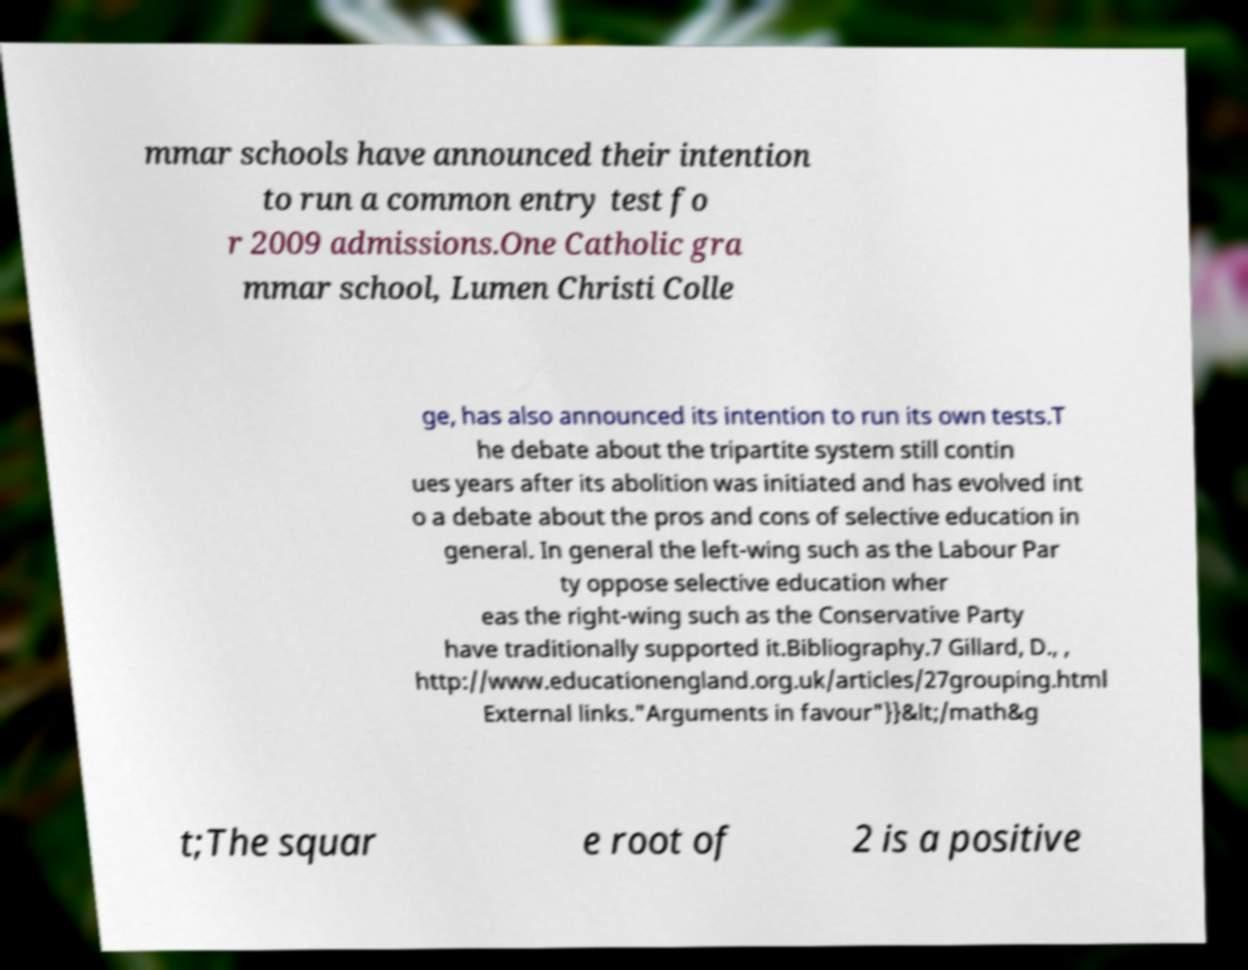For documentation purposes, I need the text within this image transcribed. Could you provide that? mmar schools have announced their intention to run a common entry test fo r 2009 admissions.One Catholic gra mmar school, Lumen Christi Colle ge, has also announced its intention to run its own tests.T he debate about the tripartite system still contin ues years after its abolition was initiated and has evolved int o a debate about the pros and cons of selective education in general. In general the left-wing such as the Labour Par ty oppose selective education wher eas the right-wing such as the Conservative Party have traditionally supported it.Bibliography.7 Gillard, D., , http://www.educationengland.org.uk/articles/27grouping.html External links."Arguments in favour"}}&lt;/math&g t;The squar e root of 2 is a positive 